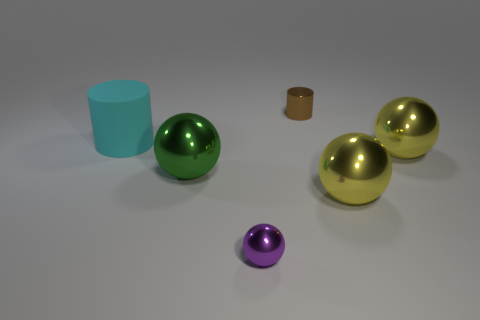Is there any pattern or symmetry in how the objects are arranged? The objects do not present an obvious pattern or symmetry. They are placed seemingly at random across the surface, with varying distances between them and no clear alignment that suggests intentional patterning or symmetrical arrangement. 